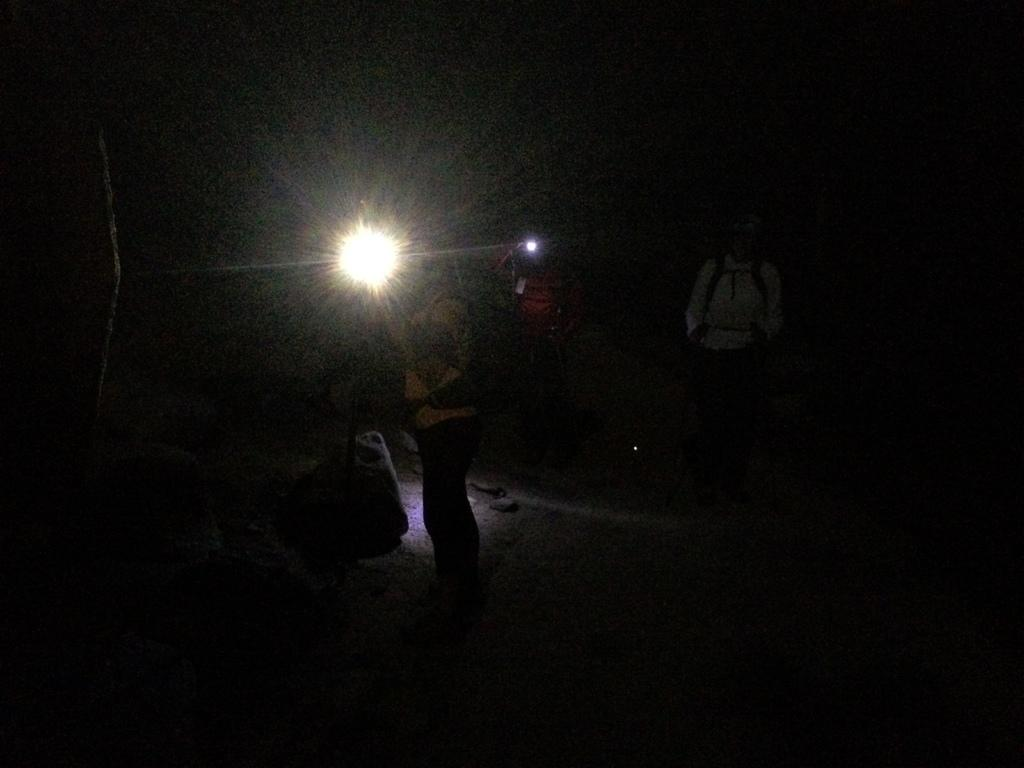How many people are in the group that is visible in the image? There is a group of persons in the image, but the exact number cannot be determined from the provided facts. What type of lighting is present in the image? There are lights in the image, but their specific type or arrangement cannot be determined from the provided facts. What other objects can be seen in the image besides the group of persons and the lights? There are many other objects in the image, but their specific nature cannot be determined from the provided facts. What is the color or tone of the background in the image? The background of the image is dark. What type of science experiment is being conducted in the ocean in the image? There is no reference to a science experiment or the ocean in the image, so it is not possible to answer that question. 